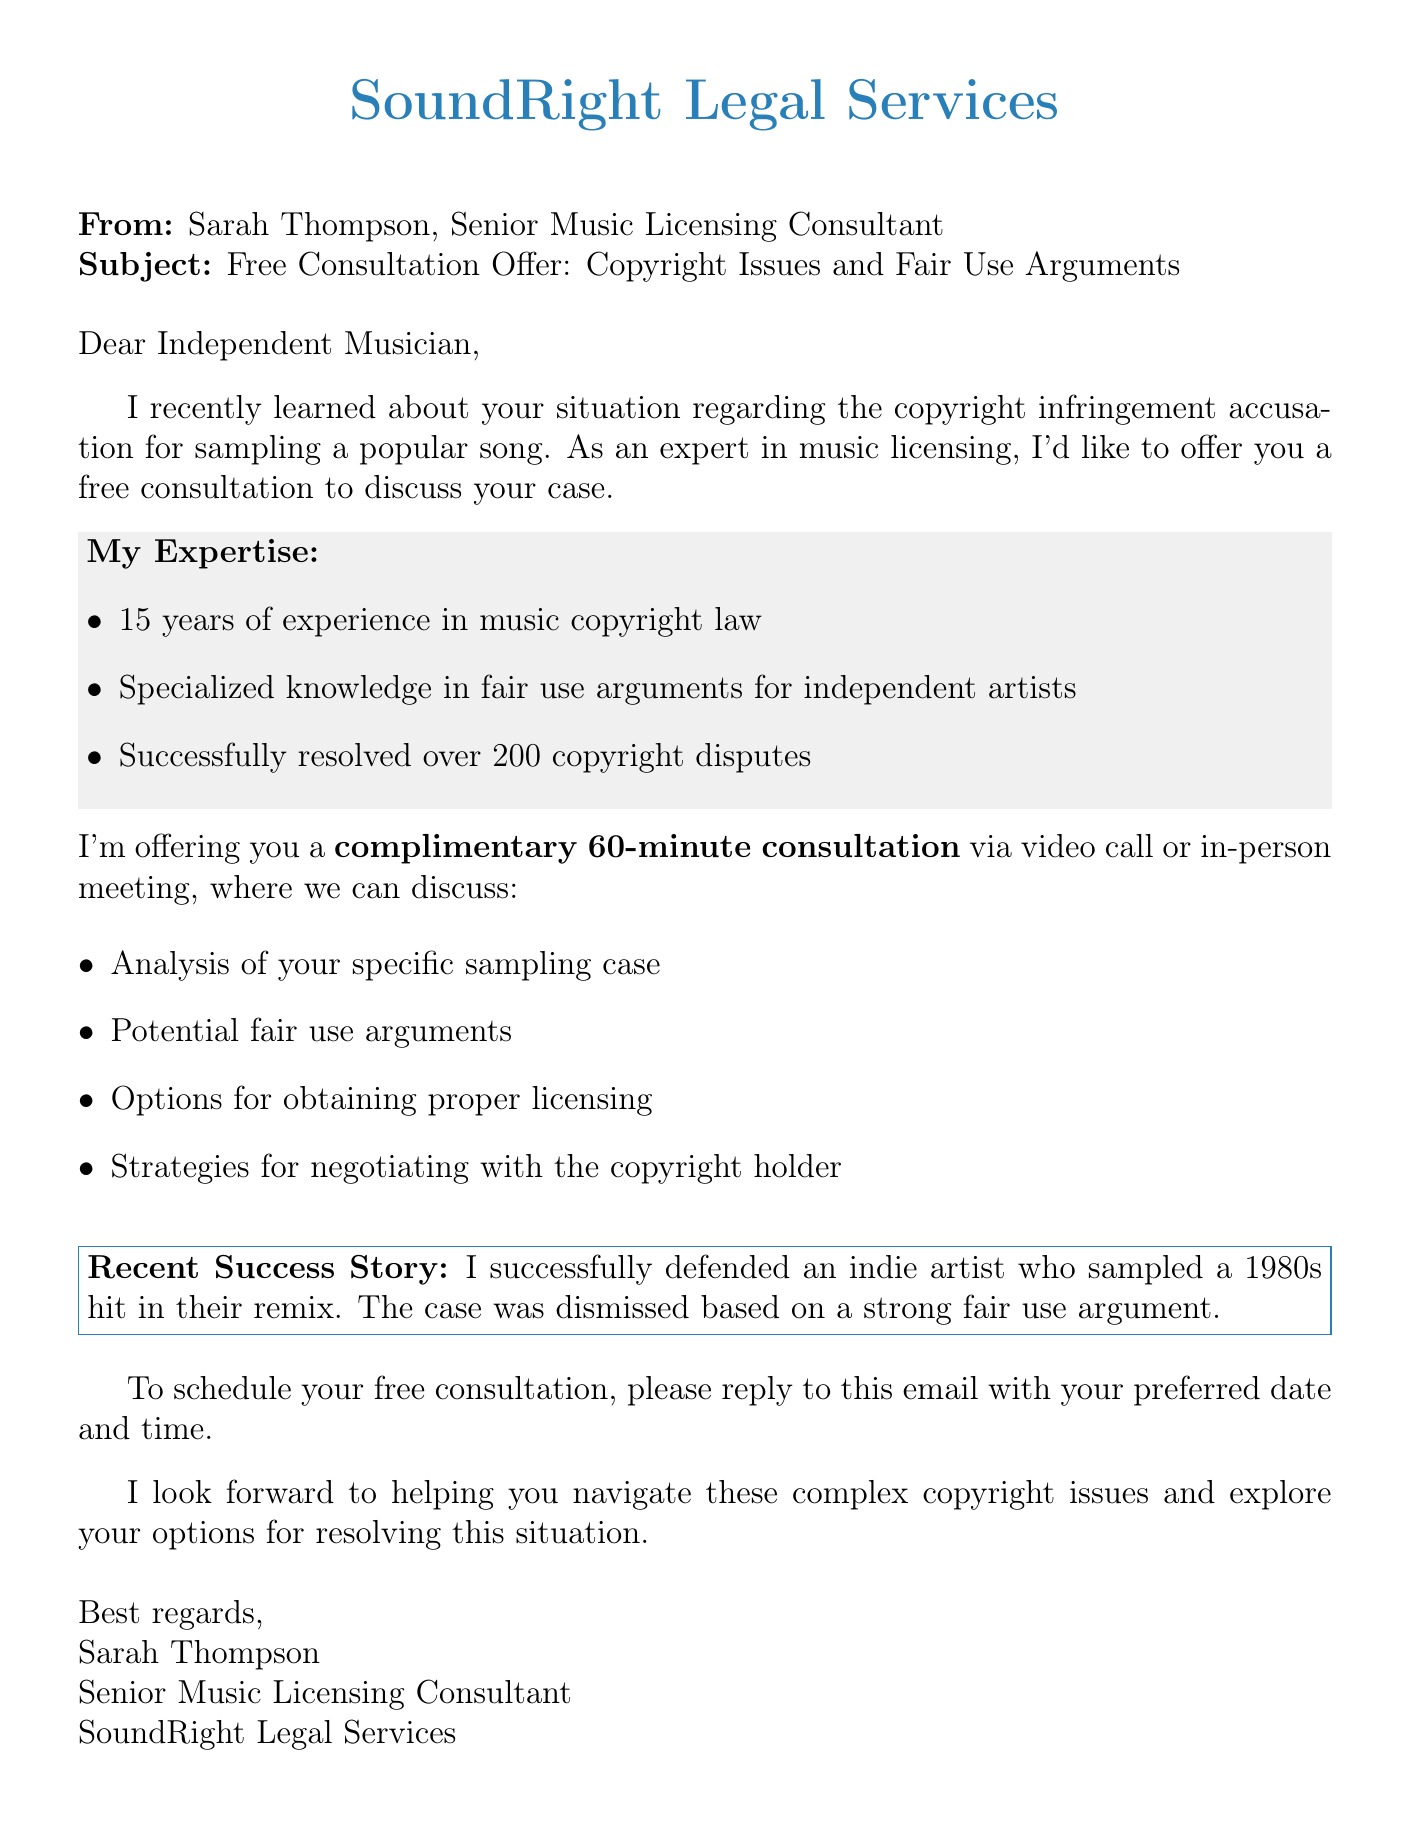what is the name of the sender? The sender's name is mentioned in the "From" section of the document.
Answer: Sarah Thompson what is the title of the sender? The title of the sender is listed right after their name in the signature.
Answer: Senior Music Licensing Consultant how many years of experience does the consultant have in music copyright law? The document specifies the number of years of experience directly in the expertise section.
Answer: 15 years what is the duration of the free consultation offered? The duration of the consultation is outlined in the consultation offer section.
Answer: 60-minute what type of consultation is being offered? The document describes the format of the consultation provided by the sender.
Answer: video call or in-person meeting what specific outcome was achieved in the recent success story? The outcome of the recent case is specified within the recent case section of the document.
Answer: Case dismissed based on fair use argument what expertise is highlighted for independent artists? The document explicitly mentions a specialized type of knowledge for a particular artist group in the expertise section.
Answer: fair use arguments for independent artists how can the musician schedule the consultation? The document states how to arrange the consultation in the call to action section.
Answer: reply to this email with your preferred date and time what company does the sender work for? The company that the sender represents is indicated at the top of the document.
Answer: SoundRight Legal Services 